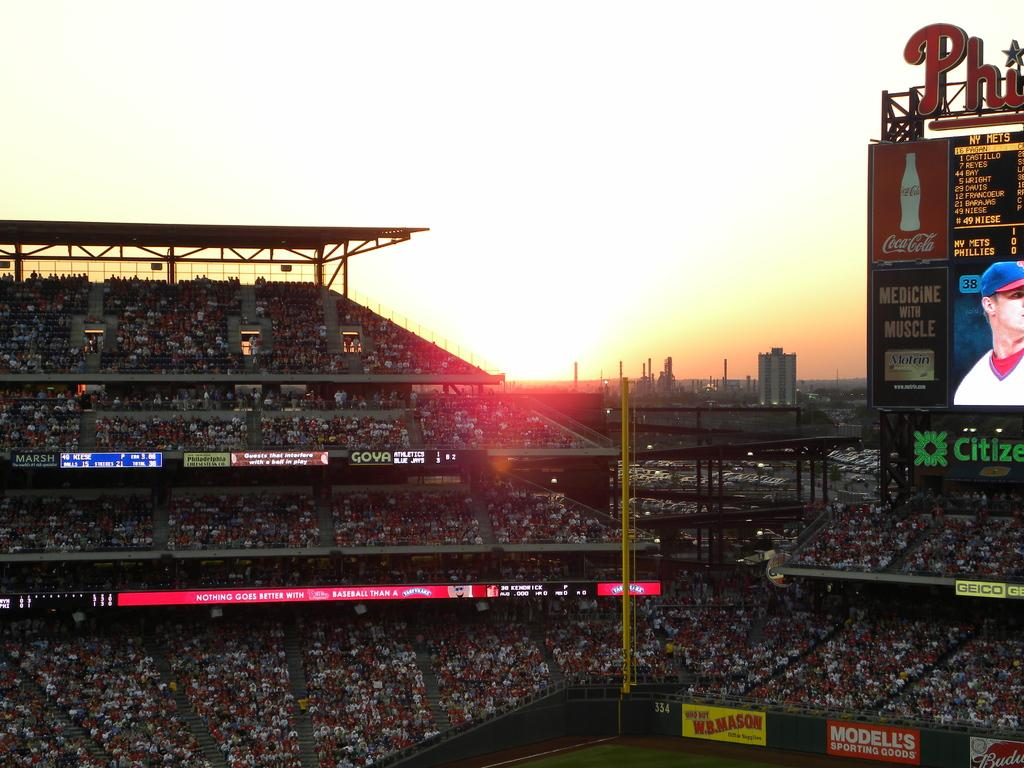Provide a one-sentence caption for the provided image. A stadium full of people with an electronic billboard that incldes an ad for Motrin. 